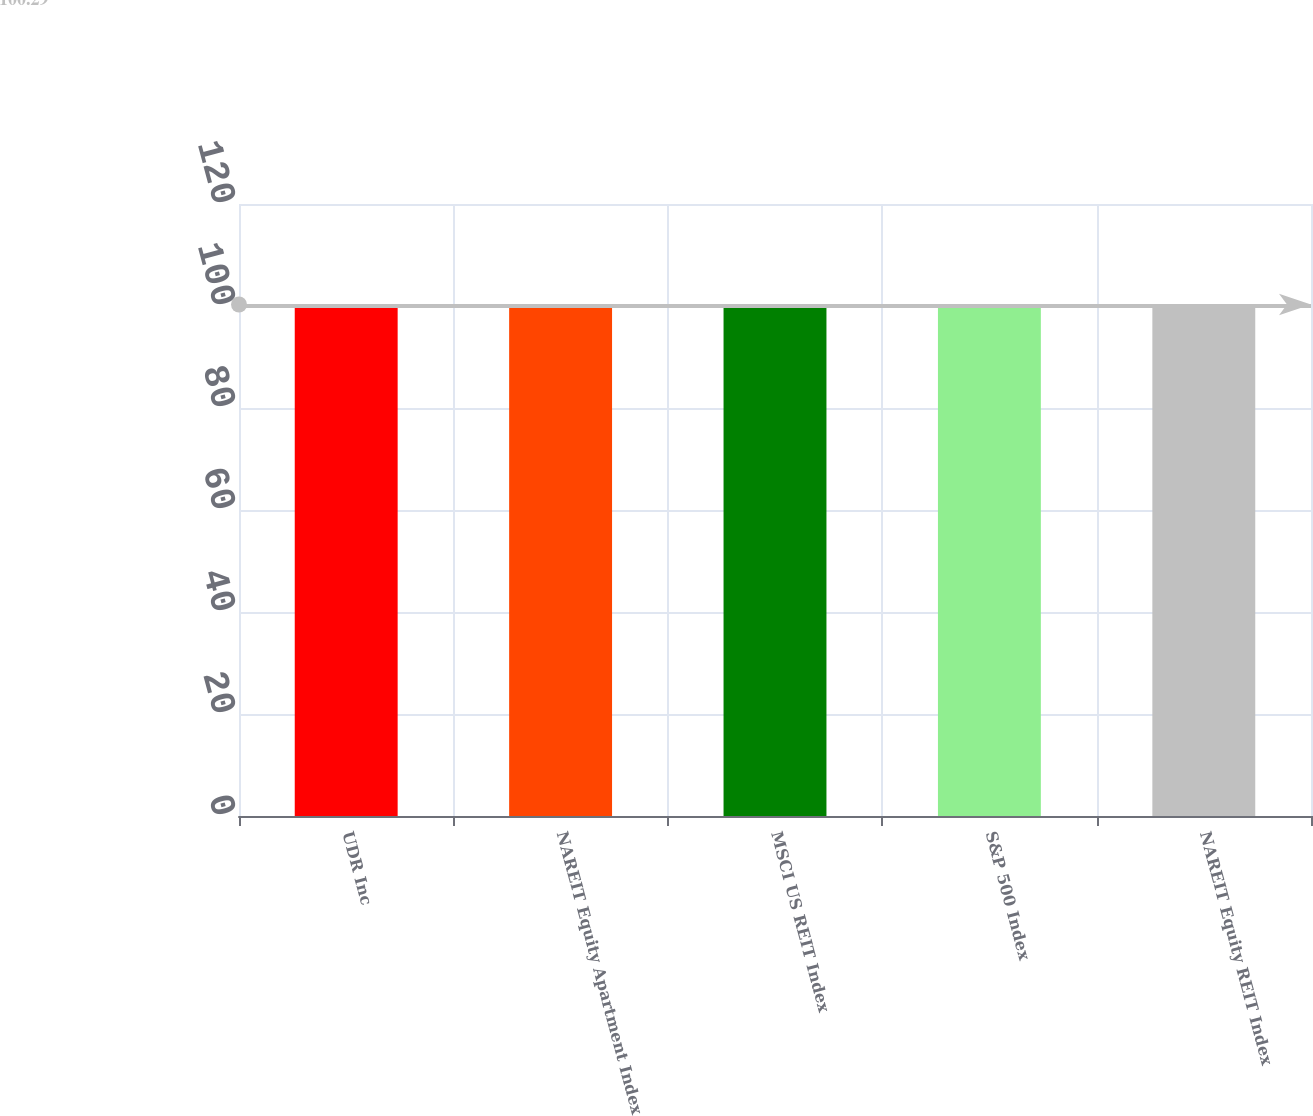Convert chart to OTSL. <chart><loc_0><loc_0><loc_500><loc_500><bar_chart><fcel>UDR Inc<fcel>NAREIT Equity Apartment Index<fcel>MSCI US REIT Index<fcel>S&P 500 Index<fcel>NAREIT Equity REIT Index<nl><fcel>100<fcel>100.1<fcel>100.2<fcel>100.3<fcel>100.4<nl></chart> 